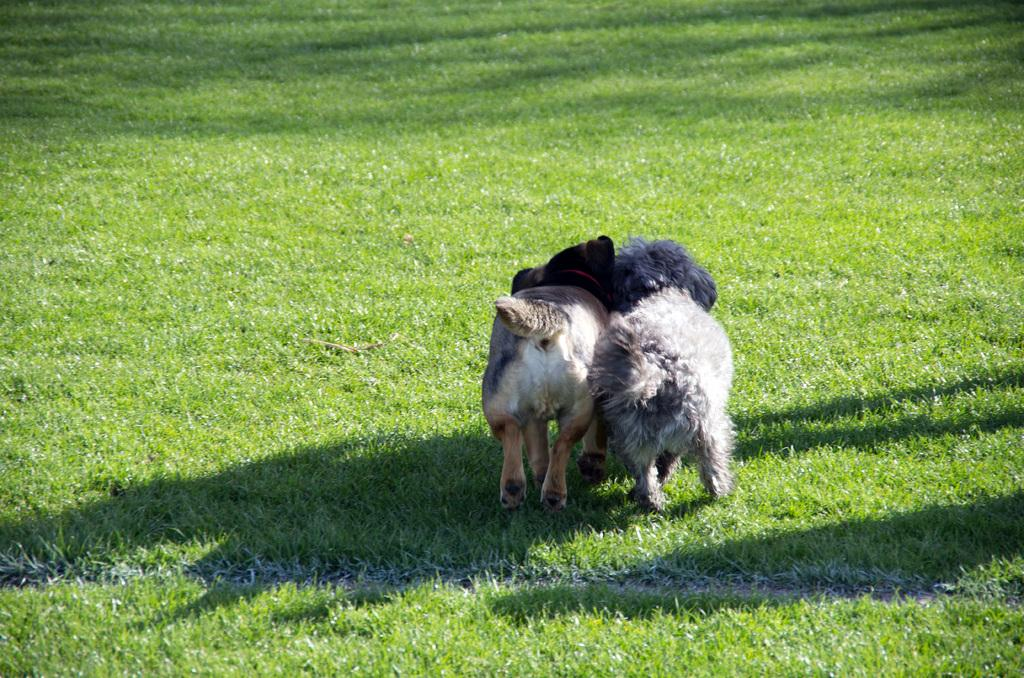How many dogs are present in the image? There are two dogs in the image. Where are the dogs located? The dogs are on the grass. Can you hear the dogs sneezing in the image? There is no sound present in the image, so we cannot hear the dogs sneezing. 